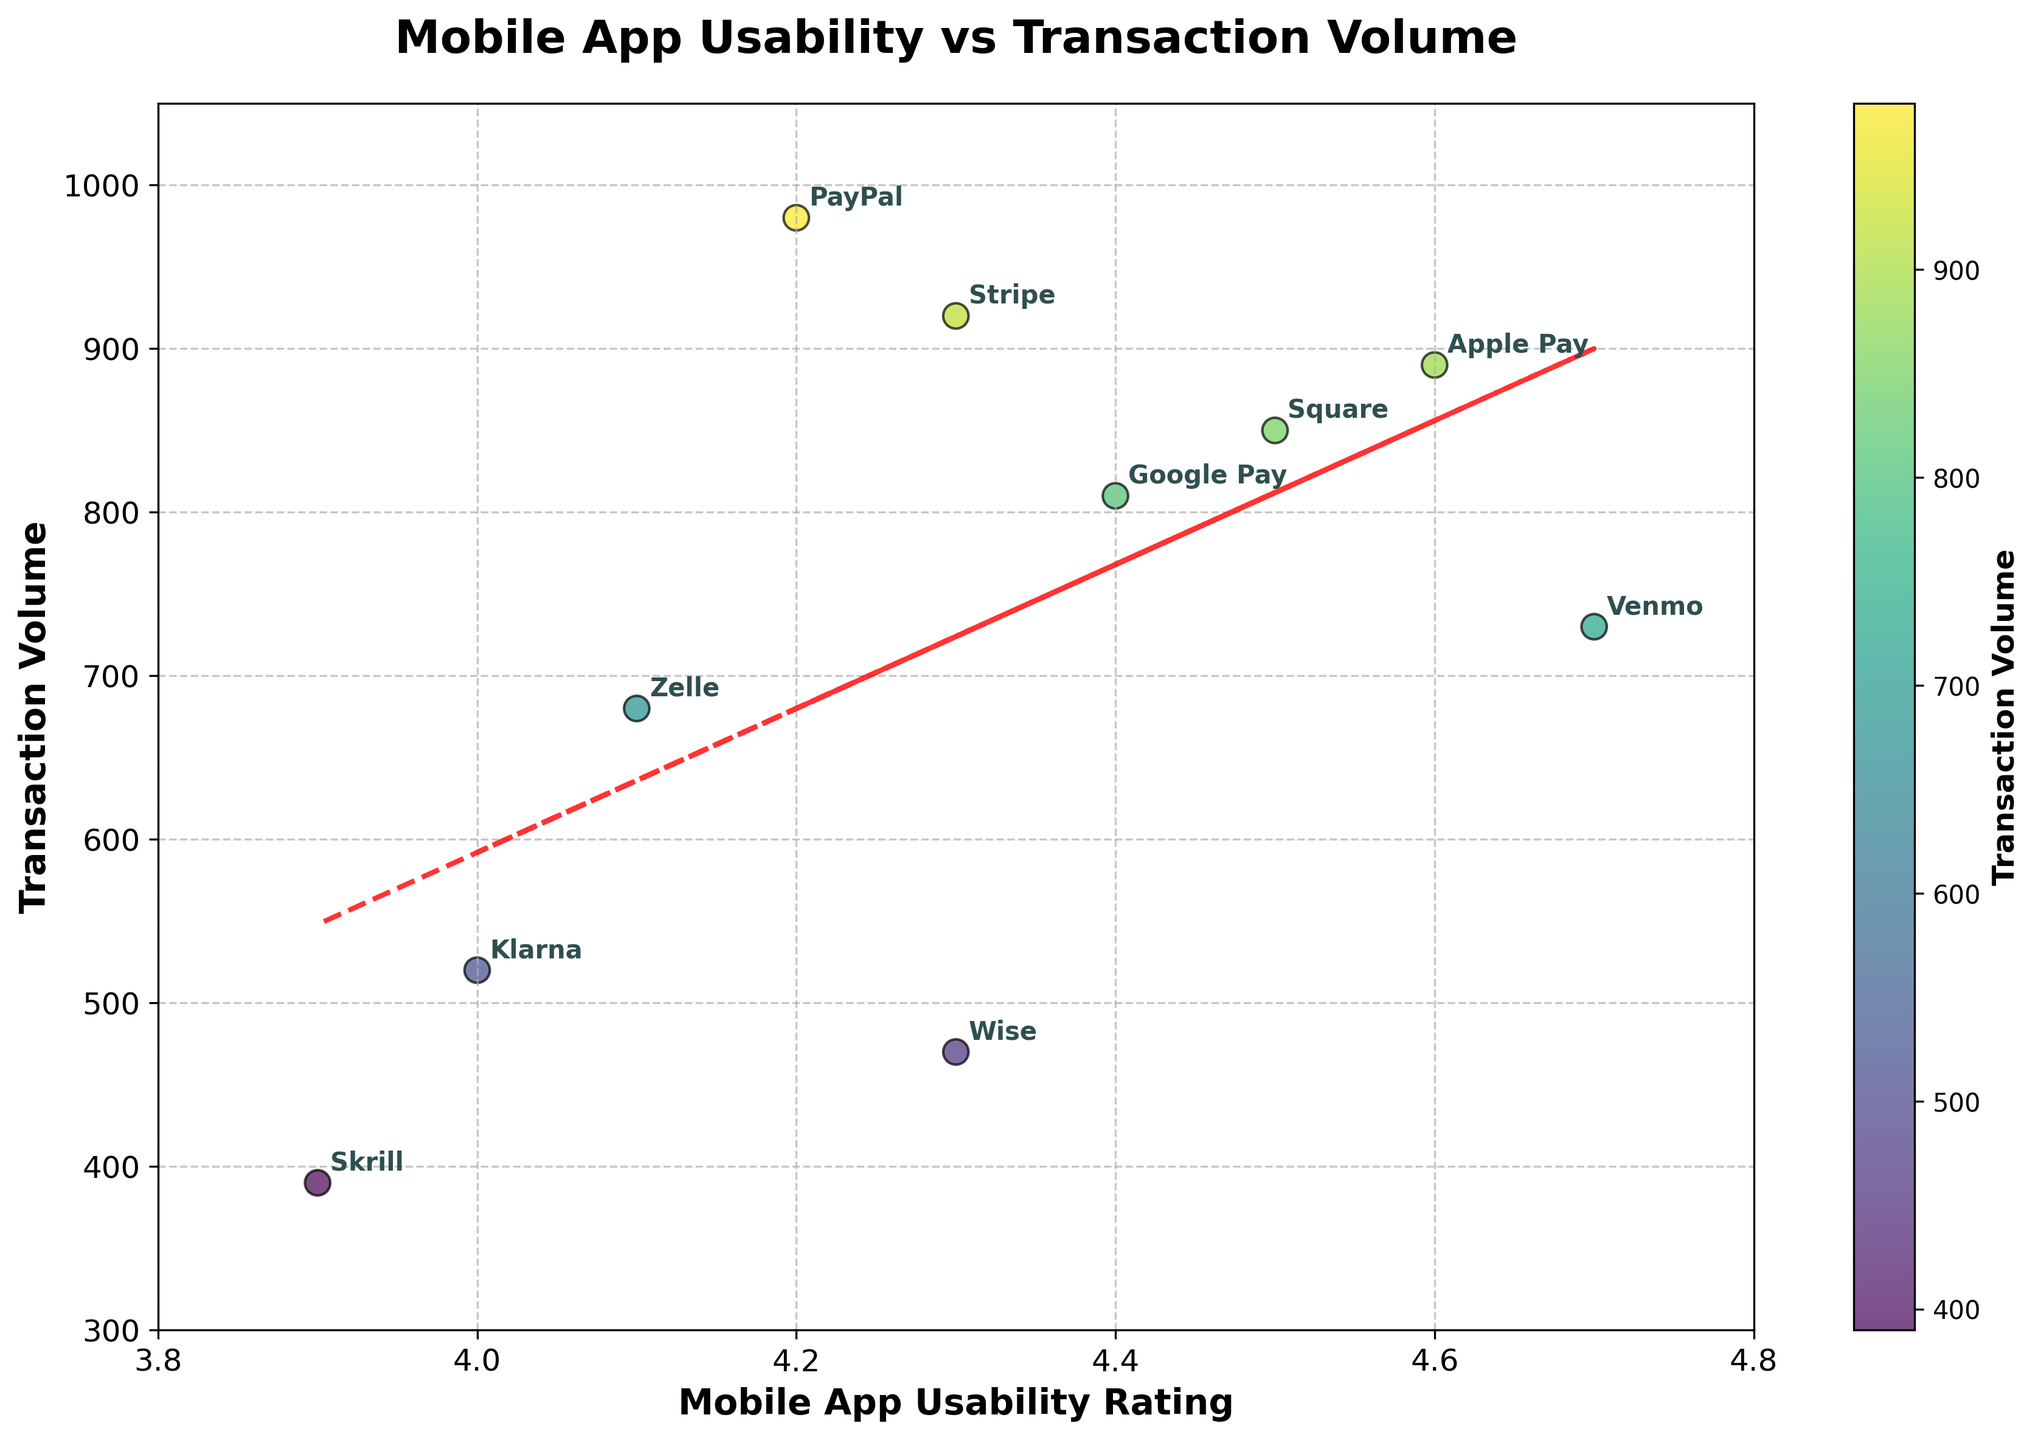What is the title of the figure? The title of the figure is located at the top center and typically describes what the plot is about. In this case, we can read the text directly from the figure title.
Answer: Mobile App Usability vs Transaction Volume How many payment services are depicted in the figure? To find the number of payment services, count the individual data points or the text labels that are annotated in the scatter plot.
Answer: 10 Which service has the highest transaction volume? To determine this, look for the data point that is plotted highest on the y-axis, and read the label associated with it.
Answer: PayPal Which service has the lowest mobile app usability rating? To identify this, look at the x-axis and find the data point that is furthest to the left, then read the label for that point.
Answer: Skrill Is there a trend between mobile app usability rating and transaction volume? A trend line is added to the plot, shown as a red dashed line. If the line slopes upwards, it indicates a positive correlation; if it slopes downwards, it indicates a negative correlation. Check the orientation of the line.
Answer: Positive correlation Between Google Pay and Apple Pay, which service has a higher transaction volume? Locate the points annotated as Google Pay and Apple Pay on the scatter plot and compare their positions along the y-axis.
Answer: Apple Pay Which two services have a similar transaction volume but a noticeable difference in mobile app usability rating? Look for two data points that are at almost the same height on the y-axis but are spaced apart on the x-axis. Identify the services associated with these points.
Answer: Square and Google Pay What is the range of mobile app usability ratings displayed on the x-axis? Check the minimum and maximum values spread across the x-axis to determine the range.
Answer: 3.9 to 4.7 Which service is closest to having a usability rating of 4.5 and a transaction volume of 850? Find the data point nearest to the coordinates (4.5, 850) by comparing the positions of the annotated points.
Answer: Square How is the usability rating of Klarna compared to Zelle? Locate both Klarna and Zelle on the x-axis and see which one is further to the right (higher rating) or to the left (lower rating).
Answer: Lower 